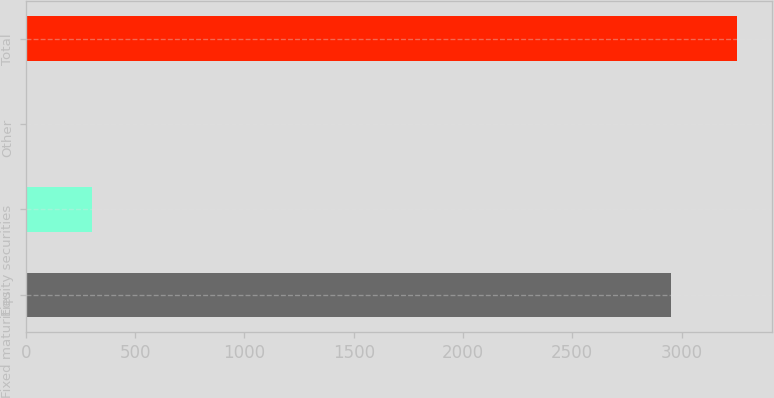Convert chart to OTSL. <chart><loc_0><loc_0><loc_500><loc_500><bar_chart><fcel>Fixed maturities<fcel>Equity securities<fcel>Other<fcel>Total<nl><fcel>2950<fcel>302.9<fcel>1<fcel>3251.9<nl></chart> 